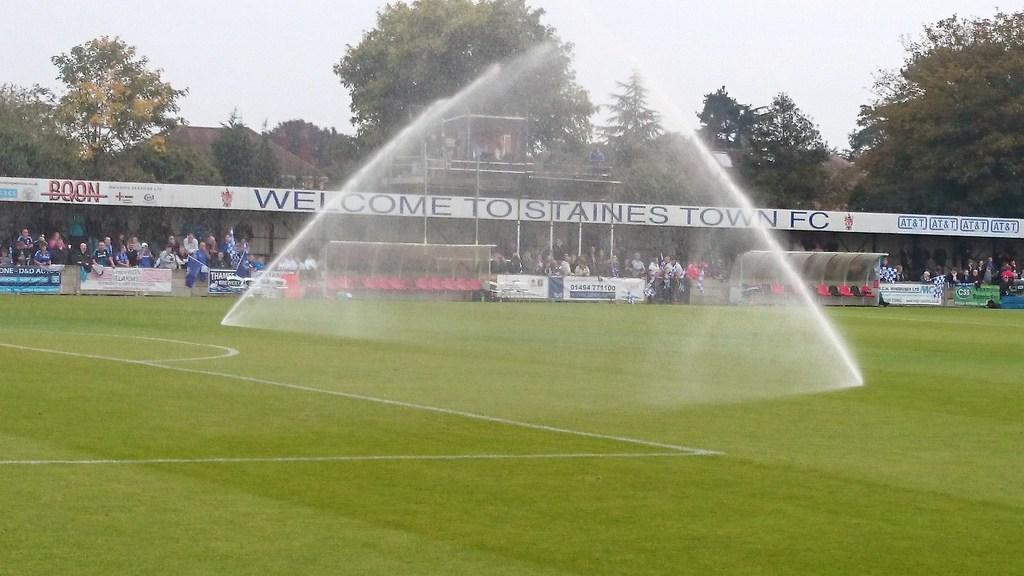<image>
Present a compact description of the photo's key features. A sports field that says Welcome To Tostaines Town FC. 